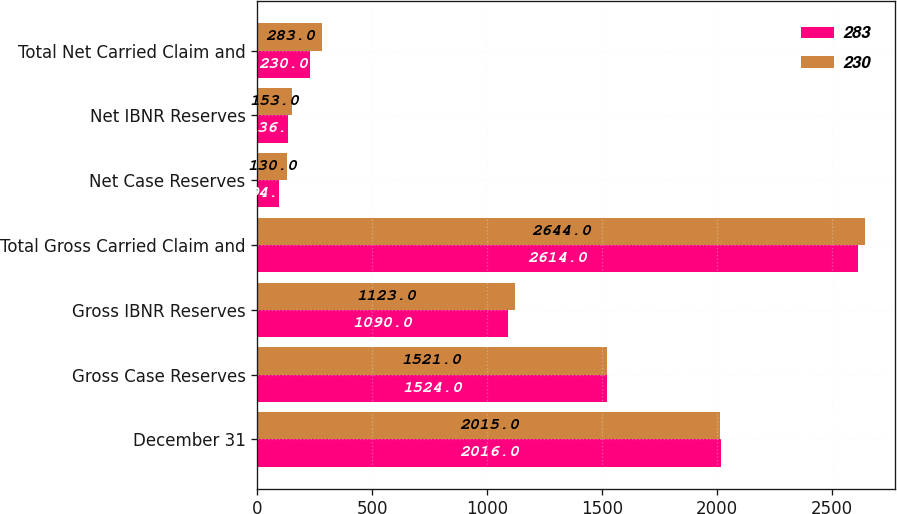Convert chart. <chart><loc_0><loc_0><loc_500><loc_500><stacked_bar_chart><ecel><fcel>December 31<fcel>Gross Case Reserves<fcel>Gross IBNR Reserves<fcel>Total Gross Carried Claim and<fcel>Net Case Reserves<fcel>Net IBNR Reserves<fcel>Total Net Carried Claim and<nl><fcel>283<fcel>2016<fcel>1524<fcel>1090<fcel>2614<fcel>94<fcel>136<fcel>230<nl><fcel>230<fcel>2015<fcel>1521<fcel>1123<fcel>2644<fcel>130<fcel>153<fcel>283<nl></chart> 